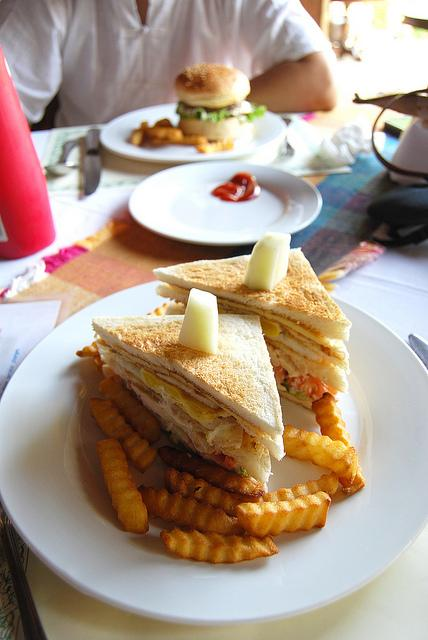What is used the make the fries have that shape? Please explain your reasoning. crinkle cutter. They are made with a special knife that cuts the indents in them. 